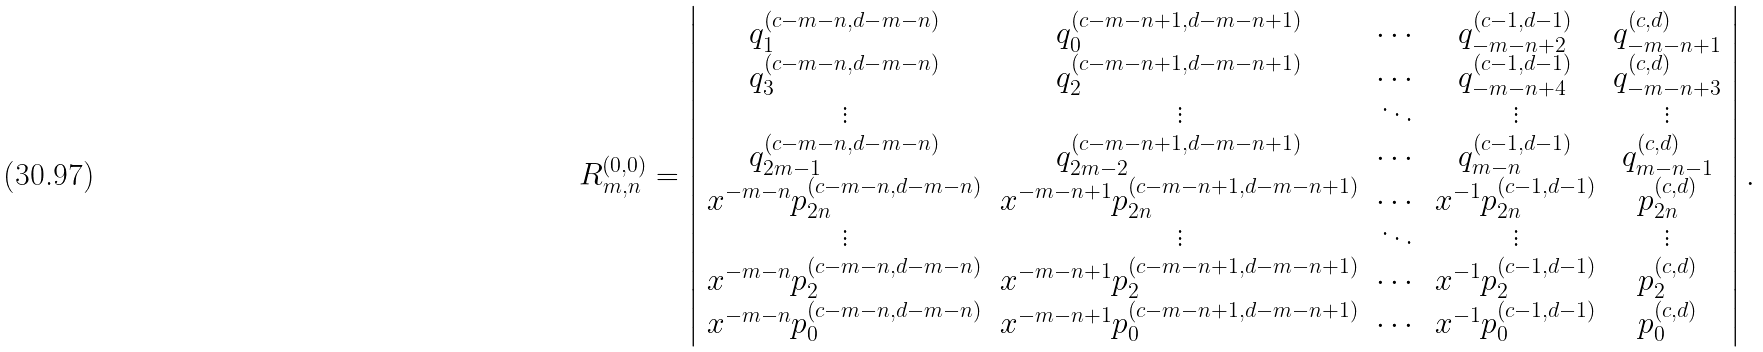<formula> <loc_0><loc_0><loc_500><loc_500>R _ { m , n } ^ { ( 0 , 0 ) } = \left | \begin{array} { c c c c c } q _ { 1 } ^ { ( c - m - n , d - m - n ) } & q _ { 0 } ^ { ( c - m - n + 1 , d - m - n + 1 ) } & \cdots & q _ { - m - n + 2 } ^ { ( c - 1 , d - 1 ) } & q _ { - m - n + 1 } ^ { ( c , d ) } \\ q _ { 3 } ^ { ( c - m - n , d - m - n ) } & q _ { 2 } ^ { ( c - m - n + 1 , d - m - n + 1 ) } & \cdots & q _ { - m - n + 4 } ^ { ( c - 1 , d - 1 ) } & q _ { - m - n + 3 } ^ { ( c , d ) } \\ \vdots & \vdots & \ddots & \vdots & \vdots \\ q _ { 2 m - 1 } ^ { ( c - m - n , d - m - n ) } & q _ { 2 m - 2 } ^ { ( c - m - n + 1 , d - m - n + 1 ) } & \cdots & q _ { m - n } ^ { ( c - 1 , d - 1 ) } & q _ { m - n - 1 } ^ { ( c , d ) } \\ x ^ { - m - n } p _ { 2 n } ^ { ( c - m - n , d - m - n ) } & x ^ { - m - n + 1 } p _ { 2 n } ^ { ( c - m - n + 1 , d - m - n + 1 ) } & \cdots & x ^ { - 1 } p _ { 2 n } ^ { ( c - 1 , d - 1 ) } & p _ { 2 n } ^ { ( c , d ) } \\ \vdots & \vdots & \ddots & \vdots & \vdots \\ x ^ { - m - n } p _ { 2 } ^ { ( c - m - n , d - m - n ) } & x ^ { - m - n + 1 } p _ { 2 } ^ { ( c - m - n + 1 , d - m - n + 1 ) } & \cdots & x ^ { - 1 } p _ { 2 } ^ { ( c - 1 , d - 1 ) } & p _ { 2 } ^ { ( c , d ) } \\ x ^ { - m - n } p _ { 0 } ^ { ( c - m - n , d - m - n ) } & x ^ { - m - n + 1 } p _ { 0 } ^ { ( c - m - n + 1 , d - m - n + 1 ) } & \cdots & x ^ { - 1 } p _ { 0 } ^ { ( c - 1 , d - 1 ) } & p _ { 0 } ^ { ( c , d ) } \end{array} \right | .</formula> 